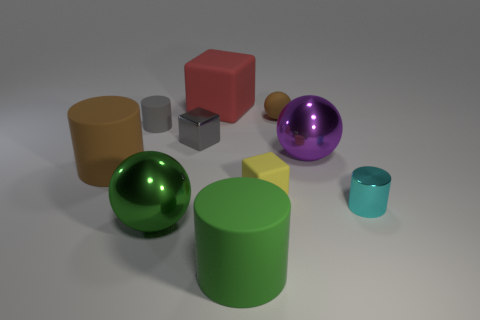There is a purple metallic object that is the same shape as the tiny brown thing; what is its size?
Ensure brevity in your answer.  Large. Are there an equal number of purple metallic things behind the large purple object and big cyan objects?
Provide a succinct answer. Yes. How many things are either large rubber cylinders that are in front of the big brown cylinder or small blue rubber cubes?
Your answer should be compact. 1. There is a big cylinder left of the large matte block; is it the same color as the rubber sphere?
Make the answer very short. Yes. There is a matte cylinder that is in front of the tiny yellow block; what size is it?
Ensure brevity in your answer.  Large. There is a brown matte object that is right of the matte block that is behind the tiny rubber cylinder; what is its shape?
Give a very brief answer. Sphere. There is a shiny thing that is the same shape as the big brown rubber object; what is its color?
Provide a short and direct response. Cyan. Is the size of the thing behind the brown matte sphere the same as the large green ball?
Keep it short and to the point. Yes. What shape is the big matte thing that is the same color as the tiny sphere?
Provide a succinct answer. Cylinder. How many big green spheres have the same material as the gray cube?
Make the answer very short. 1. 